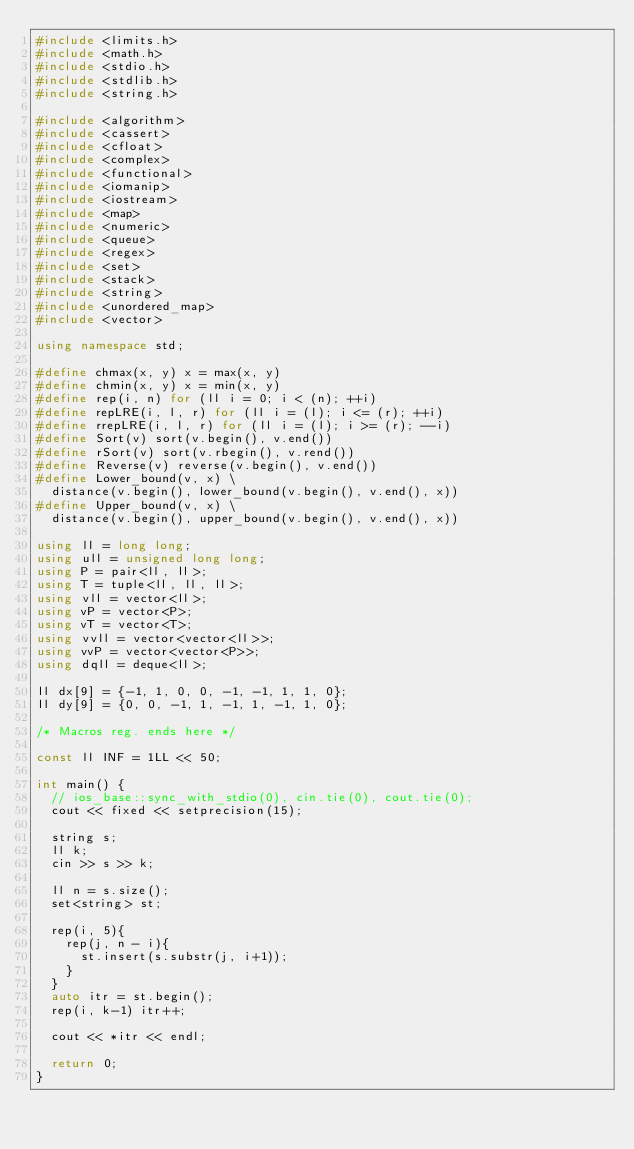<code> <loc_0><loc_0><loc_500><loc_500><_C++_>#include <limits.h>
#include <math.h>
#include <stdio.h>
#include <stdlib.h>
#include <string.h>

#include <algorithm>
#include <cassert>
#include <cfloat>
#include <complex>
#include <functional>
#include <iomanip>
#include <iostream>
#include <map>
#include <numeric>
#include <queue>
#include <regex>
#include <set>
#include <stack>
#include <string>
#include <unordered_map>
#include <vector>

using namespace std;

#define chmax(x, y) x = max(x, y)
#define chmin(x, y) x = min(x, y)
#define rep(i, n) for (ll i = 0; i < (n); ++i)
#define repLRE(i, l, r) for (ll i = (l); i <= (r); ++i)
#define rrepLRE(i, l, r) for (ll i = (l); i >= (r); --i)
#define Sort(v) sort(v.begin(), v.end())
#define rSort(v) sort(v.rbegin(), v.rend())
#define Reverse(v) reverse(v.begin(), v.end())
#define Lower_bound(v, x) \
  distance(v.begin(), lower_bound(v.begin(), v.end(), x))
#define Upper_bound(v, x) \
  distance(v.begin(), upper_bound(v.begin(), v.end(), x))

using ll = long long;
using ull = unsigned long long;
using P = pair<ll, ll>;
using T = tuple<ll, ll, ll>;
using vll = vector<ll>;
using vP = vector<P>;
using vT = vector<T>;
using vvll = vector<vector<ll>>;
using vvP = vector<vector<P>>;
using dqll = deque<ll>;

ll dx[9] = {-1, 1, 0, 0, -1, -1, 1, 1, 0};
ll dy[9] = {0, 0, -1, 1, -1, 1, -1, 1, 0};

/* Macros reg. ends here */

const ll INF = 1LL << 50;

int main() {
  // ios_base::sync_with_stdio(0), cin.tie(0), cout.tie(0);
  cout << fixed << setprecision(15);

  string s;
  ll k;
  cin >> s >> k;
   
  ll n = s.size();
  set<string> st;

  rep(i, 5){
    rep(j, n - i){
      st.insert(s.substr(j, i+1));
    }
  }
  auto itr = st.begin();
  rep(i, k-1) itr++;

  cout << *itr << endl;

  return 0;
}
</code> 